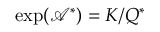Convert formula to latex. <formula><loc_0><loc_0><loc_500><loc_500>\exp ( \mathcal { A } ^ { * } ) = K \slash Q ^ { * }</formula> 